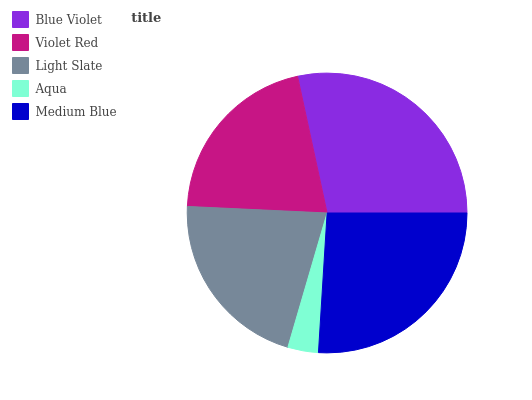Is Aqua the minimum?
Answer yes or no. Yes. Is Blue Violet the maximum?
Answer yes or no. Yes. Is Violet Red the minimum?
Answer yes or no. No. Is Violet Red the maximum?
Answer yes or no. No. Is Blue Violet greater than Violet Red?
Answer yes or no. Yes. Is Violet Red less than Blue Violet?
Answer yes or no. Yes. Is Violet Red greater than Blue Violet?
Answer yes or no. No. Is Blue Violet less than Violet Red?
Answer yes or no. No. Is Light Slate the high median?
Answer yes or no. Yes. Is Light Slate the low median?
Answer yes or no. Yes. Is Aqua the high median?
Answer yes or no. No. Is Violet Red the low median?
Answer yes or no. No. 